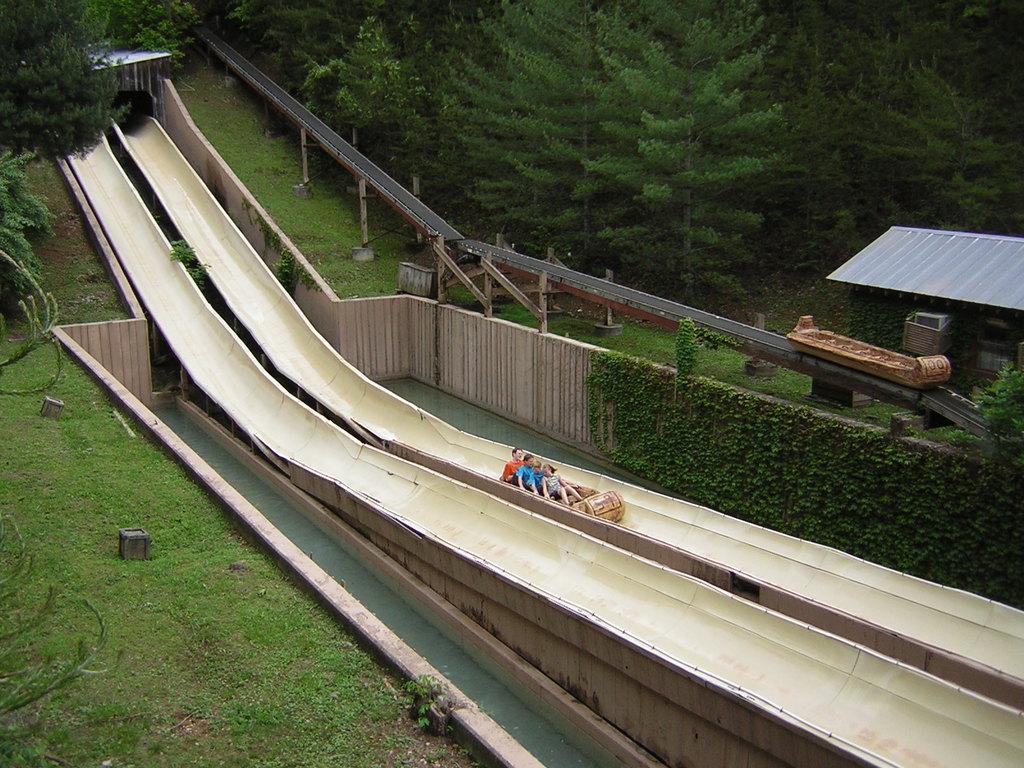How would you summarize this image in a sentence or two? On the left side, there are trees and grass on the ground. On the right side, there are three persons sitting on an object which is on a path. Beside this path, there is another path. On both sides of these paths, there is water. In the background, there is another object on another path which is on a bridge, beside this path, there is a roof and there are trees and grass on the ground. 